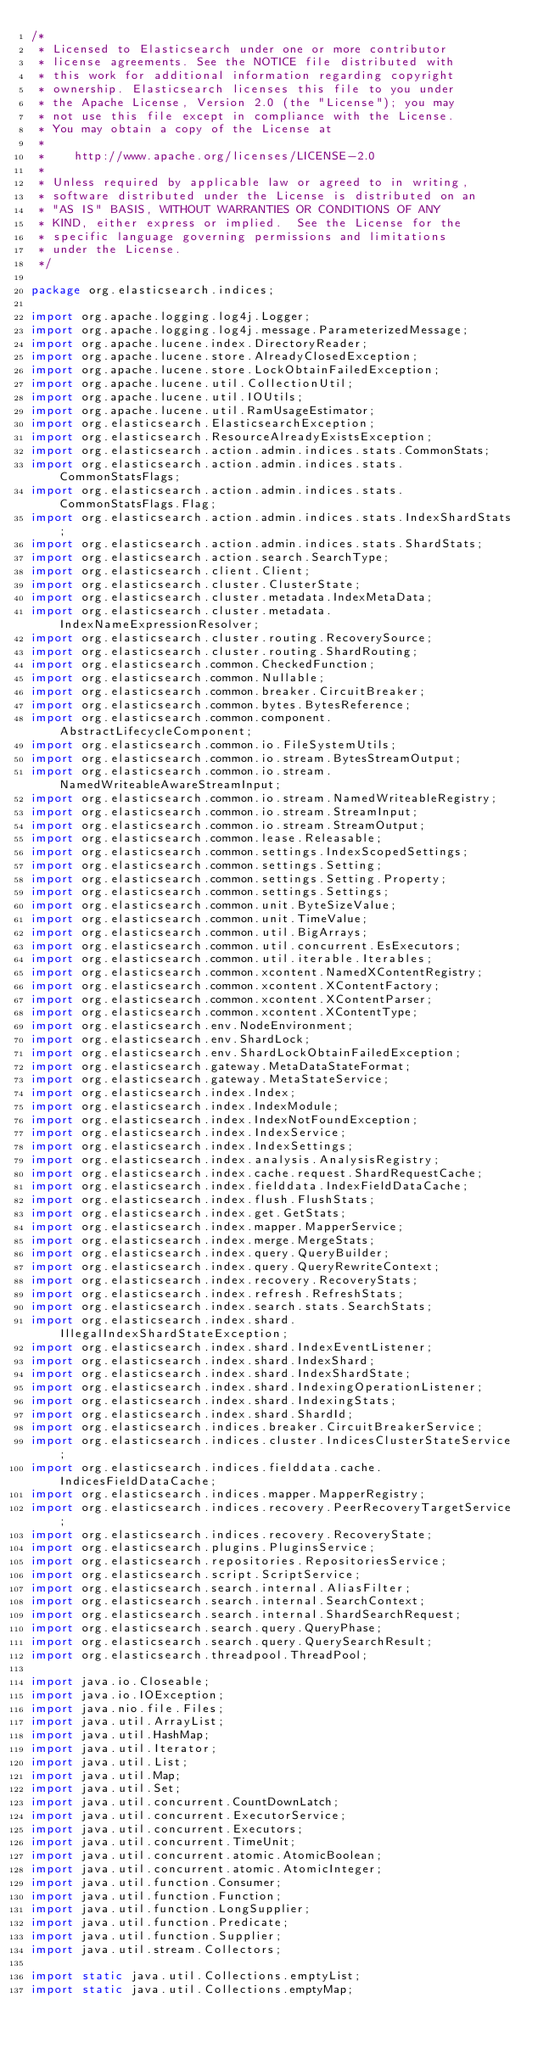Convert code to text. <code><loc_0><loc_0><loc_500><loc_500><_Java_>/*
 * Licensed to Elasticsearch under one or more contributor
 * license agreements. See the NOTICE file distributed with
 * this work for additional information regarding copyright
 * ownership. Elasticsearch licenses this file to you under
 * the Apache License, Version 2.0 (the "License"); you may
 * not use this file except in compliance with the License.
 * You may obtain a copy of the License at
 *
 *    http://www.apache.org/licenses/LICENSE-2.0
 *
 * Unless required by applicable law or agreed to in writing,
 * software distributed under the License is distributed on an
 * "AS IS" BASIS, WITHOUT WARRANTIES OR CONDITIONS OF ANY
 * KIND, either express or implied.  See the License for the
 * specific language governing permissions and limitations
 * under the License.
 */

package org.elasticsearch.indices;

import org.apache.logging.log4j.Logger;
import org.apache.logging.log4j.message.ParameterizedMessage;
import org.apache.lucene.index.DirectoryReader;
import org.apache.lucene.store.AlreadyClosedException;
import org.apache.lucene.store.LockObtainFailedException;
import org.apache.lucene.util.CollectionUtil;
import org.apache.lucene.util.IOUtils;
import org.apache.lucene.util.RamUsageEstimator;
import org.elasticsearch.ElasticsearchException;
import org.elasticsearch.ResourceAlreadyExistsException;
import org.elasticsearch.action.admin.indices.stats.CommonStats;
import org.elasticsearch.action.admin.indices.stats.CommonStatsFlags;
import org.elasticsearch.action.admin.indices.stats.CommonStatsFlags.Flag;
import org.elasticsearch.action.admin.indices.stats.IndexShardStats;
import org.elasticsearch.action.admin.indices.stats.ShardStats;
import org.elasticsearch.action.search.SearchType;
import org.elasticsearch.client.Client;
import org.elasticsearch.cluster.ClusterState;
import org.elasticsearch.cluster.metadata.IndexMetaData;
import org.elasticsearch.cluster.metadata.IndexNameExpressionResolver;
import org.elasticsearch.cluster.routing.RecoverySource;
import org.elasticsearch.cluster.routing.ShardRouting;
import org.elasticsearch.common.CheckedFunction;
import org.elasticsearch.common.Nullable;
import org.elasticsearch.common.breaker.CircuitBreaker;
import org.elasticsearch.common.bytes.BytesReference;
import org.elasticsearch.common.component.AbstractLifecycleComponent;
import org.elasticsearch.common.io.FileSystemUtils;
import org.elasticsearch.common.io.stream.BytesStreamOutput;
import org.elasticsearch.common.io.stream.NamedWriteableAwareStreamInput;
import org.elasticsearch.common.io.stream.NamedWriteableRegistry;
import org.elasticsearch.common.io.stream.StreamInput;
import org.elasticsearch.common.io.stream.StreamOutput;
import org.elasticsearch.common.lease.Releasable;
import org.elasticsearch.common.settings.IndexScopedSettings;
import org.elasticsearch.common.settings.Setting;
import org.elasticsearch.common.settings.Setting.Property;
import org.elasticsearch.common.settings.Settings;
import org.elasticsearch.common.unit.ByteSizeValue;
import org.elasticsearch.common.unit.TimeValue;
import org.elasticsearch.common.util.BigArrays;
import org.elasticsearch.common.util.concurrent.EsExecutors;
import org.elasticsearch.common.util.iterable.Iterables;
import org.elasticsearch.common.xcontent.NamedXContentRegistry;
import org.elasticsearch.common.xcontent.XContentFactory;
import org.elasticsearch.common.xcontent.XContentParser;
import org.elasticsearch.common.xcontent.XContentType;
import org.elasticsearch.env.NodeEnvironment;
import org.elasticsearch.env.ShardLock;
import org.elasticsearch.env.ShardLockObtainFailedException;
import org.elasticsearch.gateway.MetaDataStateFormat;
import org.elasticsearch.gateway.MetaStateService;
import org.elasticsearch.index.Index;
import org.elasticsearch.index.IndexModule;
import org.elasticsearch.index.IndexNotFoundException;
import org.elasticsearch.index.IndexService;
import org.elasticsearch.index.IndexSettings;
import org.elasticsearch.index.analysis.AnalysisRegistry;
import org.elasticsearch.index.cache.request.ShardRequestCache;
import org.elasticsearch.index.fielddata.IndexFieldDataCache;
import org.elasticsearch.index.flush.FlushStats;
import org.elasticsearch.index.get.GetStats;
import org.elasticsearch.index.mapper.MapperService;
import org.elasticsearch.index.merge.MergeStats;
import org.elasticsearch.index.query.QueryBuilder;
import org.elasticsearch.index.query.QueryRewriteContext;
import org.elasticsearch.index.recovery.RecoveryStats;
import org.elasticsearch.index.refresh.RefreshStats;
import org.elasticsearch.index.search.stats.SearchStats;
import org.elasticsearch.index.shard.IllegalIndexShardStateException;
import org.elasticsearch.index.shard.IndexEventListener;
import org.elasticsearch.index.shard.IndexShard;
import org.elasticsearch.index.shard.IndexShardState;
import org.elasticsearch.index.shard.IndexingOperationListener;
import org.elasticsearch.index.shard.IndexingStats;
import org.elasticsearch.index.shard.ShardId;
import org.elasticsearch.indices.breaker.CircuitBreakerService;
import org.elasticsearch.indices.cluster.IndicesClusterStateService;
import org.elasticsearch.indices.fielddata.cache.IndicesFieldDataCache;
import org.elasticsearch.indices.mapper.MapperRegistry;
import org.elasticsearch.indices.recovery.PeerRecoveryTargetService;
import org.elasticsearch.indices.recovery.RecoveryState;
import org.elasticsearch.plugins.PluginsService;
import org.elasticsearch.repositories.RepositoriesService;
import org.elasticsearch.script.ScriptService;
import org.elasticsearch.search.internal.AliasFilter;
import org.elasticsearch.search.internal.SearchContext;
import org.elasticsearch.search.internal.ShardSearchRequest;
import org.elasticsearch.search.query.QueryPhase;
import org.elasticsearch.search.query.QuerySearchResult;
import org.elasticsearch.threadpool.ThreadPool;

import java.io.Closeable;
import java.io.IOException;
import java.nio.file.Files;
import java.util.ArrayList;
import java.util.HashMap;
import java.util.Iterator;
import java.util.List;
import java.util.Map;
import java.util.Set;
import java.util.concurrent.CountDownLatch;
import java.util.concurrent.ExecutorService;
import java.util.concurrent.Executors;
import java.util.concurrent.TimeUnit;
import java.util.concurrent.atomic.AtomicBoolean;
import java.util.concurrent.atomic.AtomicInteger;
import java.util.function.Consumer;
import java.util.function.Function;
import java.util.function.LongSupplier;
import java.util.function.Predicate;
import java.util.function.Supplier;
import java.util.stream.Collectors;

import static java.util.Collections.emptyList;
import static java.util.Collections.emptyMap;</code> 